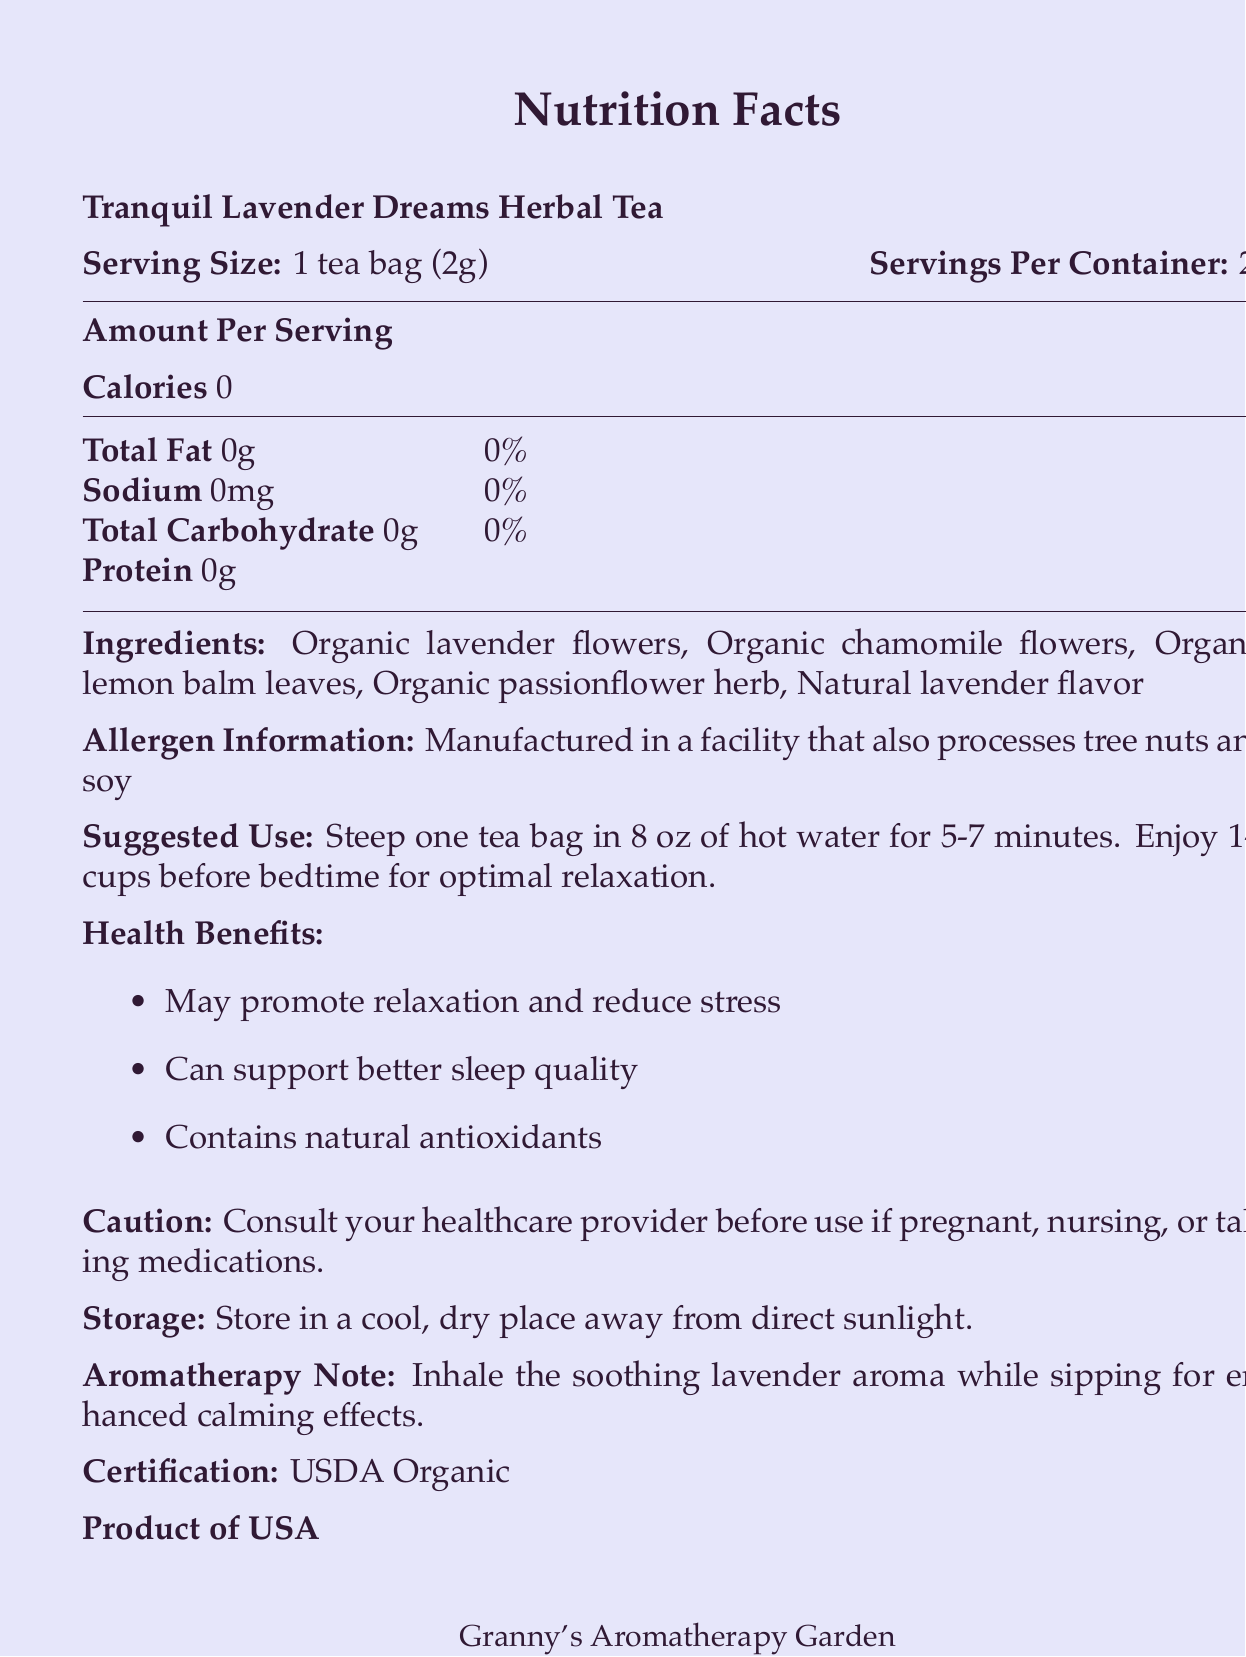what is the serving size? The serving size is explicitly stated as "1 tea bag (2g)" in the document.
Answer: 1 tea bag (2g) how many calories are in one serving of the tea? The document lists the calories per serving as 0.
Answer: 0 what are the ingredients of the tea? The document details the ingredients clearly under the "Ingredients" section.
Answer: Organic lavender flowers, Organic chamomile flowers, Organic lemon balm leaves, Organic passionflower herb, Natural lavender flavor how many servings are there per container? The document specifies that there are 20 servings per container.
Answer: 20 where is the product manufactured? The document states "Product of USA".
Answer: USA which herbal ingredient is not included in the blend? A. Organic chamomile flowers B. Ginseng C. Organic lemon balm leaves D. Organic passionflower herb The document lists the other ingredients but does not mention Ginseng.
Answer: B how long should you steep one tea bag for optimal relaxation? The document advises steeping the tea bag for 5-7 minutes in the "Suggested Use" section.
Answer: 5-7 minutes is there any fat content in the tea? The document indicates the total fat content as 0g, which means there is no fat in the tea.
Answer: No what should you do if you are pregnant or nursing before using this tea? The document cautions to consult your healthcare provider if you are pregnant, nursing, or taking medications.
Answer: Consult your healthcare provider what are the health benefits of the tea? The health benefits are listed in the document under the "Health Benefits" section.
Answer: May promote relaxation and reduce stress, can support better sleep quality, contains natural antioxidants what is the certification status of the product? The document notes that the product is USDA Organic certified.
Answer: USDA Organic is the tea manufactured in a facility that processes tree nuts and soy? The document's allergen information mentions that the facility also processes tree nuts and soy.
Answer: Yes summarize the main idea of the document. The document gives a comprehensive view of the herbal tea product, from nutritional facts to health benefits, and usage guidance, promoting its relaxing properties.
Answer: The document provides the nutritional information, ingredient list, health benefits, and usage instructions for "Tranquil Lavender Dreams Herbal Tea." It highlights the tea's zero-calorie content, organic ingredients, and relaxing properties. Additionally, it includes cautions, storage instructions, and certification details. what is the company's contact address? The company's address is listed at the end of the document.
Answer: 123 Lavender Lane, Serenity Springs, CA 90210 how many grams of protein are in one serving? The document states that the protein content per serving is 0g.
Answer: 0g what are the suggested conditions for storing the tea? The storage instructions are specifically provided in the document.
Answer: Store in a cool, dry place away from direct sunlight. according to the document, how many antioxidants are in the tea? The document mentions the presence of natural antioxidants but does not quantify them.
Answer: Not enough information 